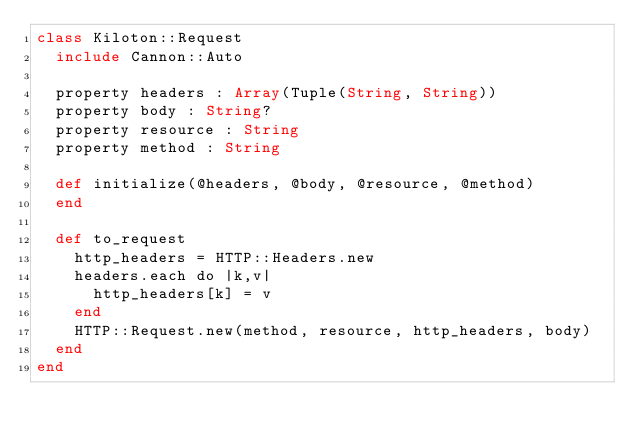<code> <loc_0><loc_0><loc_500><loc_500><_Crystal_>class Kiloton::Request
  include Cannon::Auto

  property headers : Array(Tuple(String, String))
  property body : String?
  property resource : String
  property method : String

  def initialize(@headers, @body, @resource, @method)
  end

  def to_request
    http_headers = HTTP::Headers.new
    headers.each do |k,v|
      http_headers[k] = v
    end
    HTTP::Request.new(method, resource, http_headers, body)
  end
end
</code> 